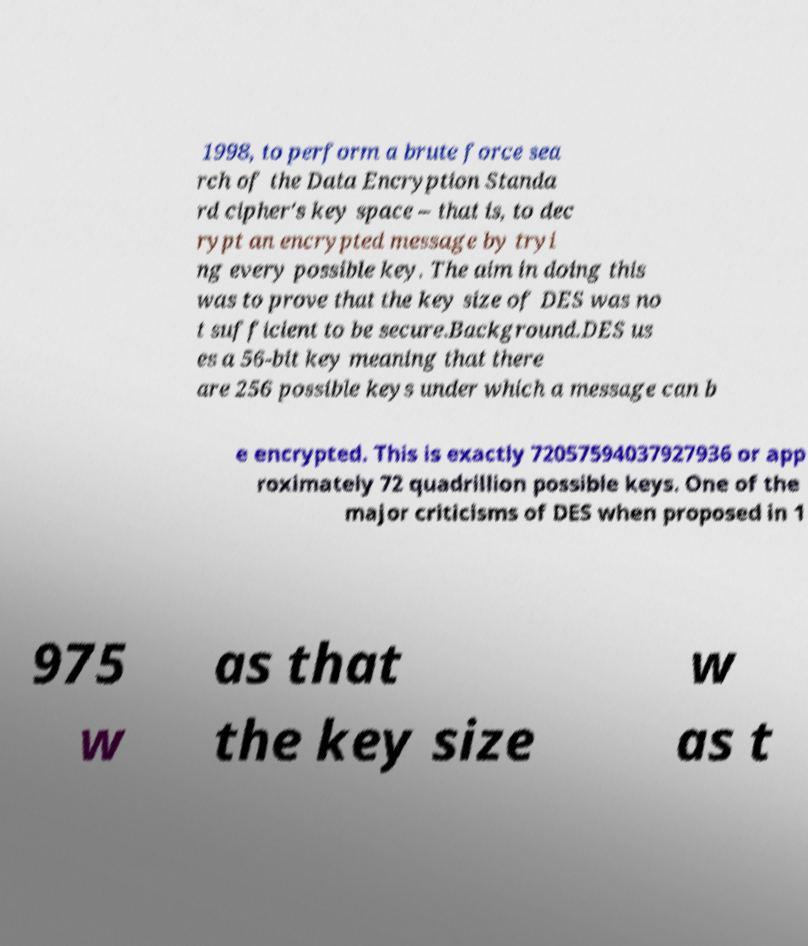Please read and relay the text visible in this image. What does it say? 1998, to perform a brute force sea rch of the Data Encryption Standa rd cipher's key space – that is, to dec rypt an encrypted message by tryi ng every possible key. The aim in doing this was to prove that the key size of DES was no t sufficient to be secure.Background.DES us es a 56-bit key meaning that there are 256 possible keys under which a message can b e encrypted. This is exactly 72057594037927936 or app roximately 72 quadrillion possible keys. One of the major criticisms of DES when proposed in 1 975 w as that the key size w as t 